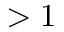Convert formula to latex. <formula><loc_0><loc_0><loc_500><loc_500>> 1</formula> 